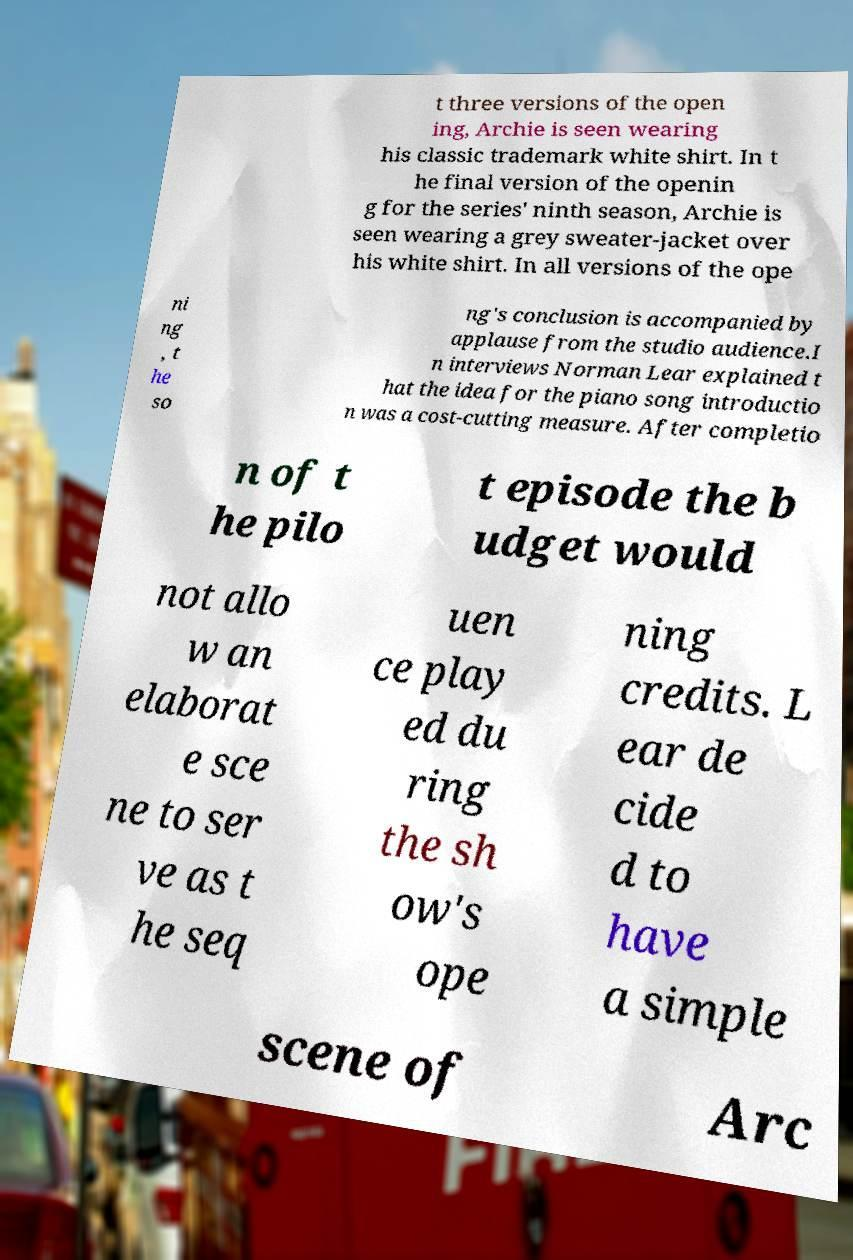Could you extract and type out the text from this image? t three versions of the open ing, Archie is seen wearing his classic trademark white shirt. In t he final version of the openin g for the series' ninth season, Archie is seen wearing a grey sweater-jacket over his white shirt. In all versions of the ope ni ng , t he so ng's conclusion is accompanied by applause from the studio audience.I n interviews Norman Lear explained t hat the idea for the piano song introductio n was a cost-cutting measure. After completio n of t he pilo t episode the b udget would not allo w an elaborat e sce ne to ser ve as t he seq uen ce play ed du ring the sh ow's ope ning credits. L ear de cide d to have a simple scene of Arc 